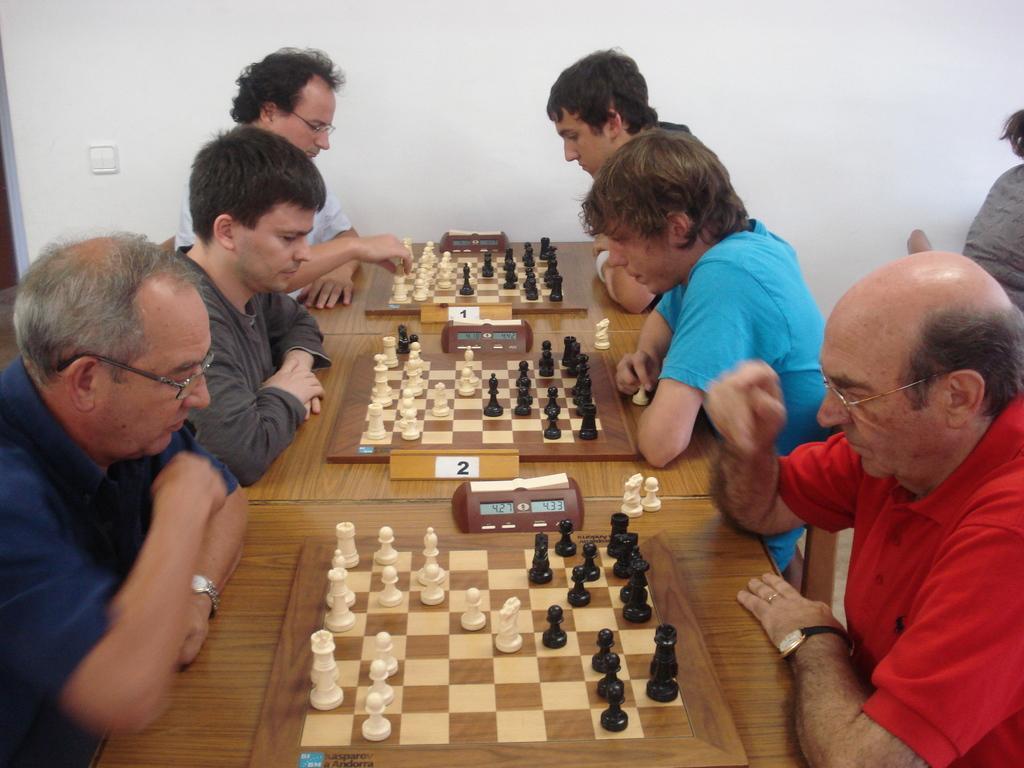Could you give a brief overview of what you see in this image? In the center of the image there are tables and we can see chess boards placed on it. There are chess pieces and we can see people sitting. In the background there is a wall. 